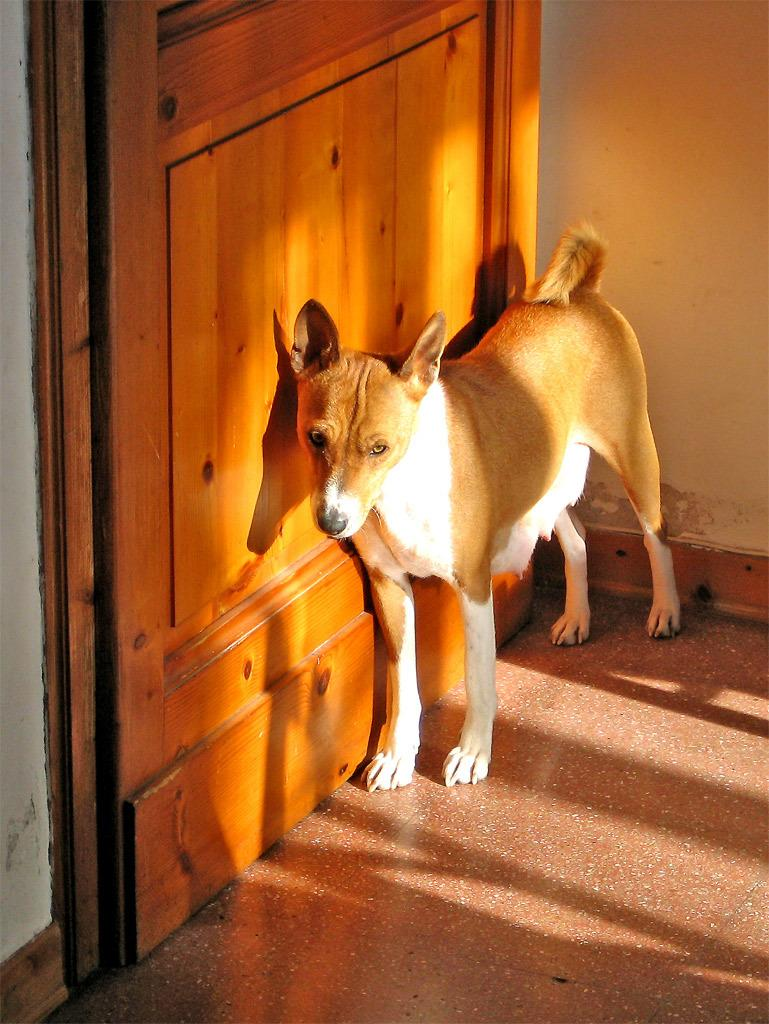What animal is standing on the floor in the image? There is a dog standing on the floor in the image. What type of door is located beside the dog? There is a wooden door beside the dog. What can be seen behind the dog in the image? There is a wall visible in the image. What type of popcorn is being served to the dog's friends in the image? There is no popcorn or friends present in the image; it only features a dog standing on the floor beside a wooden door and a wall. 